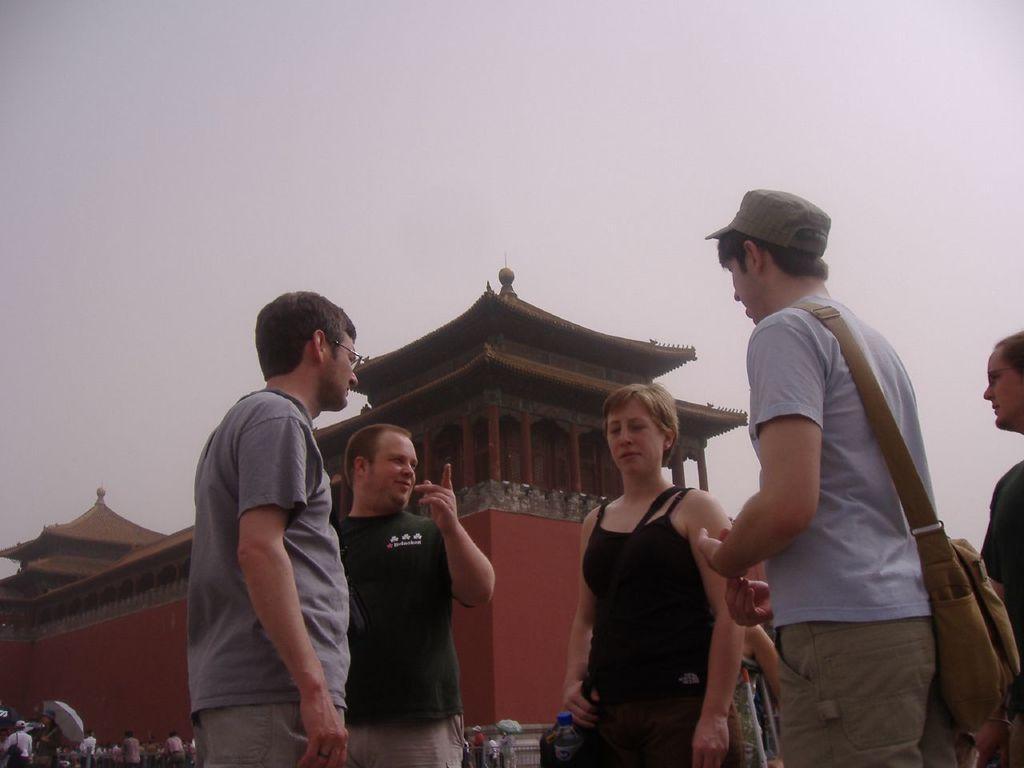Please provide a concise description of this image. In this picture I can see group of people standing, there are two persons holding the umbrellas, this is looking like a Chinese building, and in the background there is sky. 